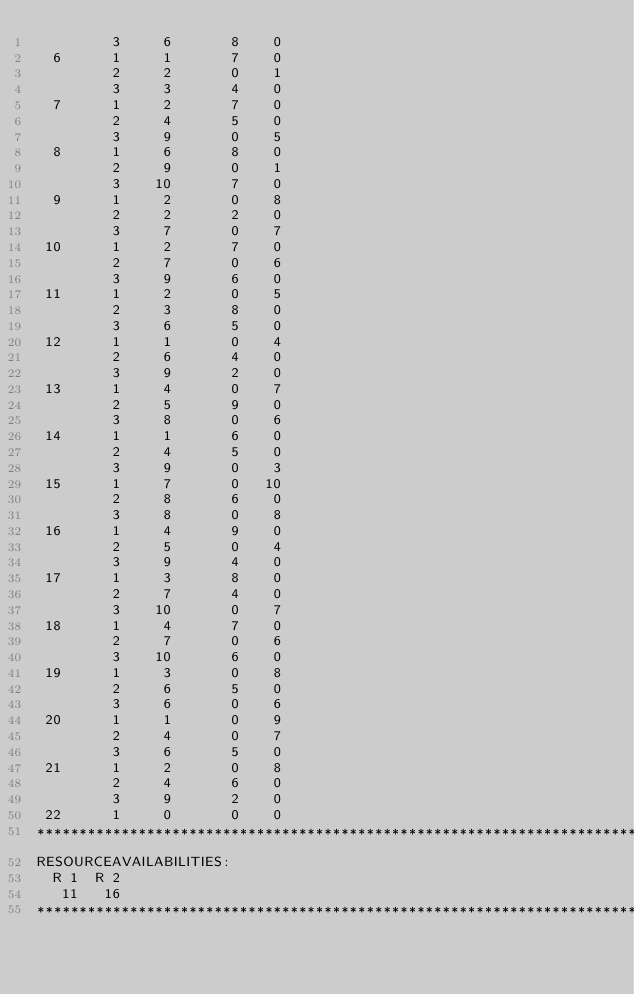<code> <loc_0><loc_0><loc_500><loc_500><_ObjectiveC_>         3     6       8    0
  6      1     1       7    0
         2     2       0    1
         3     3       4    0
  7      1     2       7    0
         2     4       5    0
         3     9       0    5
  8      1     6       8    0
         2     9       0    1
         3    10       7    0
  9      1     2       0    8
         2     2       2    0
         3     7       0    7
 10      1     2       7    0
         2     7       0    6
         3     9       6    0
 11      1     2       0    5
         2     3       8    0
         3     6       5    0
 12      1     1       0    4
         2     6       4    0
         3     9       2    0
 13      1     4       0    7
         2     5       9    0
         3     8       0    6
 14      1     1       6    0
         2     4       5    0
         3     9       0    3
 15      1     7       0   10
         2     8       6    0
         3     8       0    8
 16      1     4       9    0
         2     5       0    4
         3     9       4    0
 17      1     3       8    0
         2     7       4    0
         3    10       0    7
 18      1     4       7    0
         2     7       0    6
         3    10       6    0
 19      1     3       0    8
         2     6       5    0
         3     6       0    6
 20      1     1       0    9
         2     4       0    7
         3     6       5    0
 21      1     2       0    8
         2     4       6    0
         3     9       2    0
 22      1     0       0    0
************************************************************************
RESOURCEAVAILABILITIES:
  R 1  R 2
   11   16
************************************************************************
</code> 